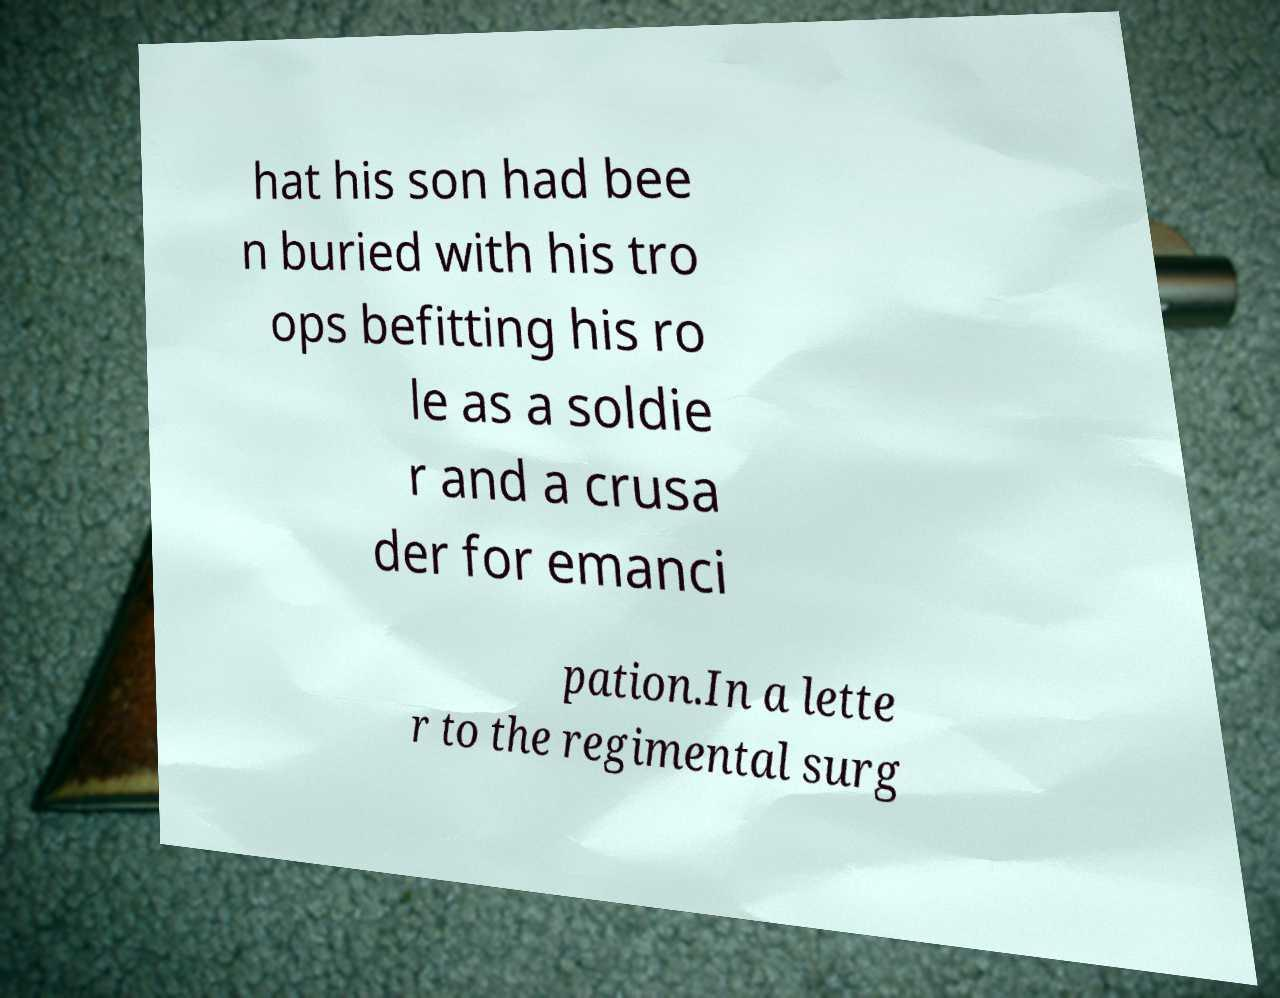For documentation purposes, I need the text within this image transcribed. Could you provide that? hat his son had bee n buried with his tro ops befitting his ro le as a soldie r and a crusa der for emanci pation.In a lette r to the regimental surg 